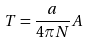<formula> <loc_0><loc_0><loc_500><loc_500>T = \frac { a } { 4 \pi N } A</formula> 